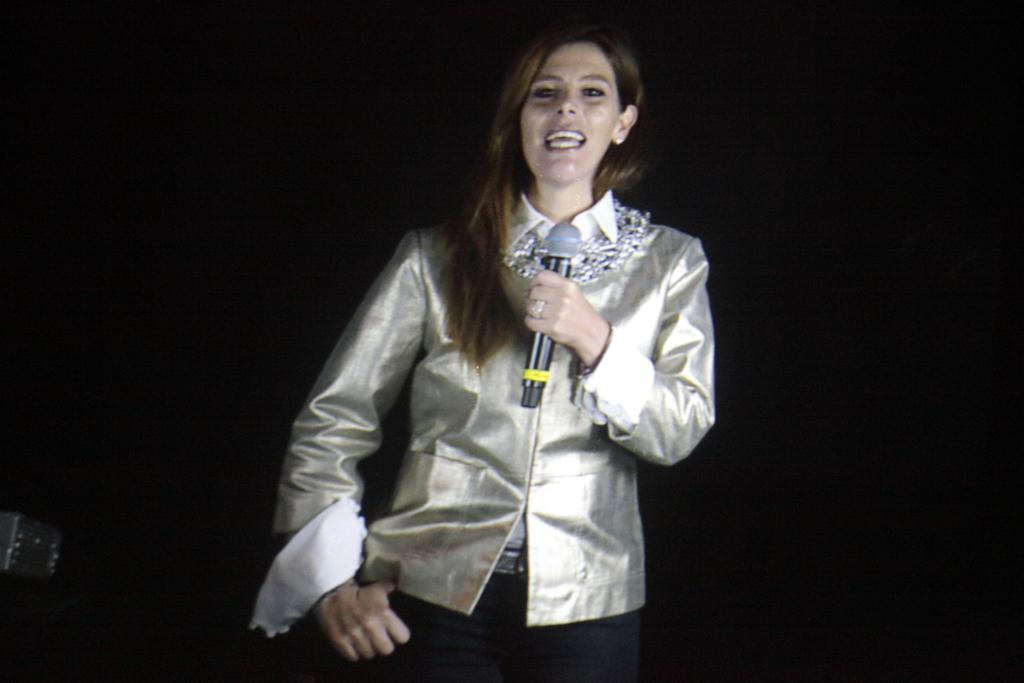How would you summarize this image in a sentence or two? In this image we can see a woman standing and holding a mic and the background it is dark. 